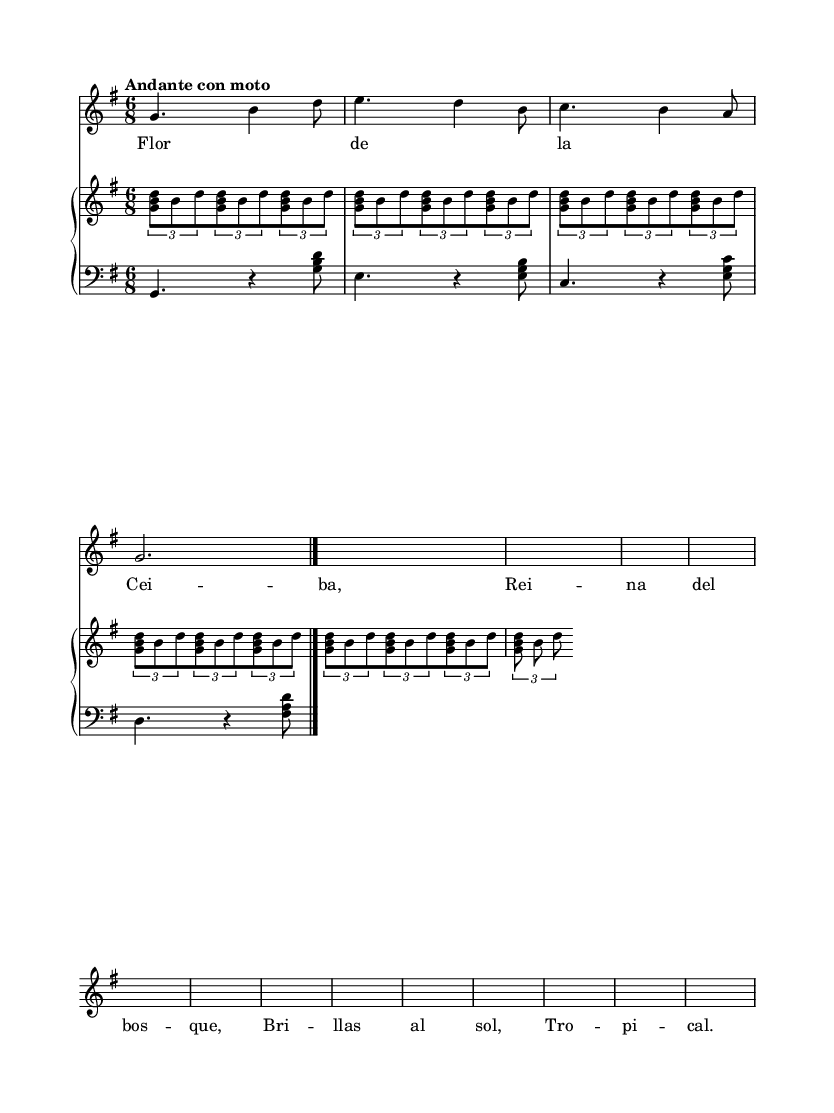What is the key signature of this music? The key signature is G major, which consists of one sharp (F#).
Answer: G major What is the time signature of this piece? The time signature is 6/8, indicating six eighth notes per measure.
Answer: 6/8 What is the tempo marking for this piece? The tempo marking is "Andante con moto," which means moderately slow with movement.
Answer: Andante con moto How many measures are there in the soprano part? There are four measures in the soprano part, as indicated by the divisions in the music.
Answer: Four measures What is the dynamic marking at the end of the soprano line? The dynamic marking at the end is a forte, indicated by the \f symbol.
Answer: Forte How many notes are included in the tuplets for the piano right hand? There are three notes included in each tuplet of the piano right hand, as indicated by the 3/2 notation.
Answer: Three notes What is the main theme of the opera as reflected in the lyrics? The main theme of the opera is celebrating tropical flora, specifically highlighted by the mention of "Flor de la Ceiba."
Answer: Tropical flora 